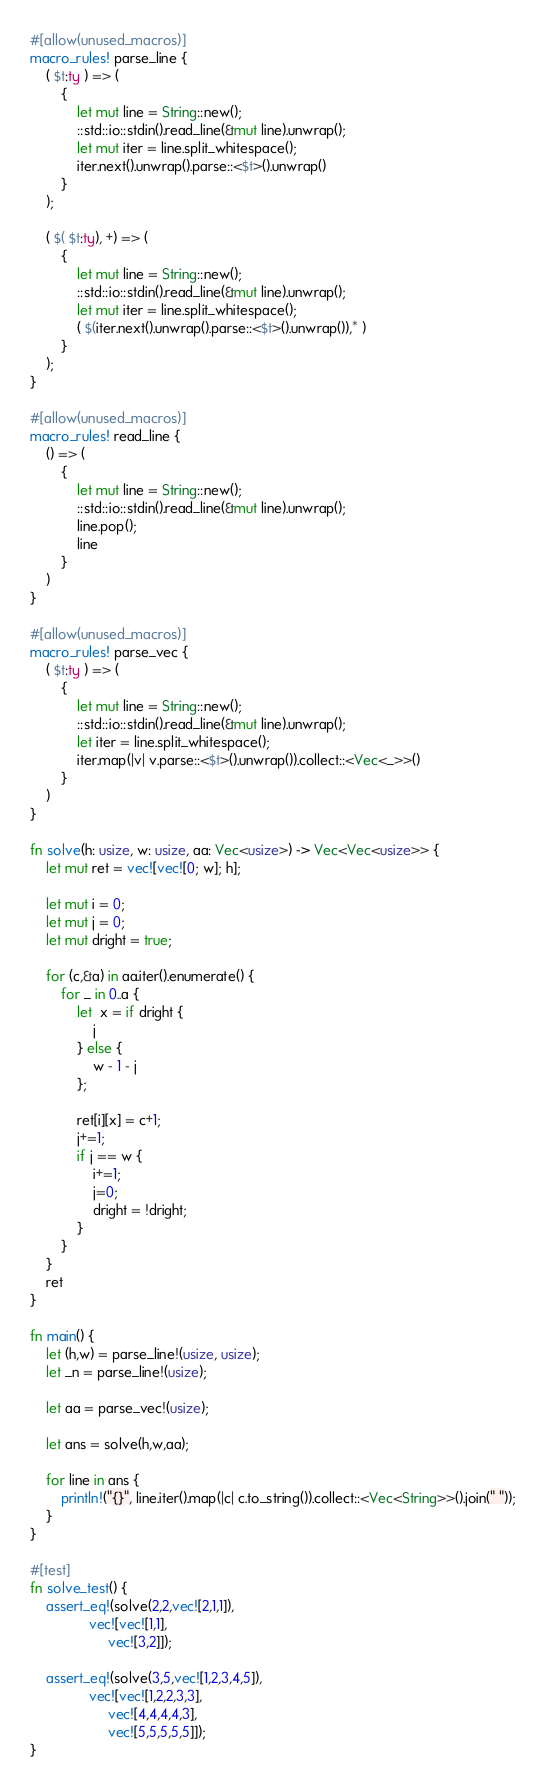Convert code to text. <code><loc_0><loc_0><loc_500><loc_500><_Rust_>#[allow(unused_macros)]
macro_rules! parse_line {
    ( $t:ty ) => (
        {
            let mut line = String::new();
            ::std::io::stdin().read_line(&mut line).unwrap();
            let mut iter = line.split_whitespace();
            iter.next().unwrap().parse::<$t>().unwrap()
        }
    );

    ( $( $t:ty), +) => (
        {
            let mut line = String::new();
            ::std::io::stdin().read_line(&mut line).unwrap();
            let mut iter = line.split_whitespace();
            ( $(iter.next().unwrap().parse::<$t>().unwrap()),* )
        }
    );
}

#[allow(unused_macros)]
macro_rules! read_line {
    () => (
        {
            let mut line = String::new();
            ::std::io::stdin().read_line(&mut line).unwrap();
            line.pop();
            line
        }
    )
}

#[allow(unused_macros)]
macro_rules! parse_vec {
    ( $t:ty ) => (
        {
            let mut line = String::new();
            ::std::io::stdin().read_line(&mut line).unwrap();
            let iter = line.split_whitespace();
            iter.map(|v| v.parse::<$t>().unwrap()).collect::<Vec<_>>()
        }
    )
}

fn solve(h: usize, w: usize, aa: Vec<usize>) -> Vec<Vec<usize>> {
    let mut ret = vec![vec![0; w]; h];

    let mut i = 0;
    let mut j = 0;
    let mut dright = true;

    for (c,&a) in aa.iter().enumerate() {
        for _ in 0..a {
            let  x = if dright {
                j
            } else {
                w - 1 - j
            };

            ret[i][x] = c+1;
            j+=1;
            if j == w {
                i+=1;
                j=0;
                dright = !dright;
            }
        }
    }
    ret
}

fn main() {
    let (h,w) = parse_line!(usize, usize);
    let _n = parse_line!(usize);

    let aa = parse_vec!(usize);

    let ans = solve(h,w,aa);

    for line in ans {
        println!("{}", line.iter().map(|c| c.to_string()).collect::<Vec<String>>().join(" "));
    }
}

#[test]
fn solve_test() {
    assert_eq!(solve(2,2,vec![2,1,1]),
               vec![vec![1,1],
                    vec![3,2]]);

    assert_eq!(solve(3,5,vec![1,2,3,4,5]),
               vec![vec![1,2,2,3,3],
                    vec![4,4,4,4,3],
                    vec![5,5,5,5,5]]);
}
</code> 